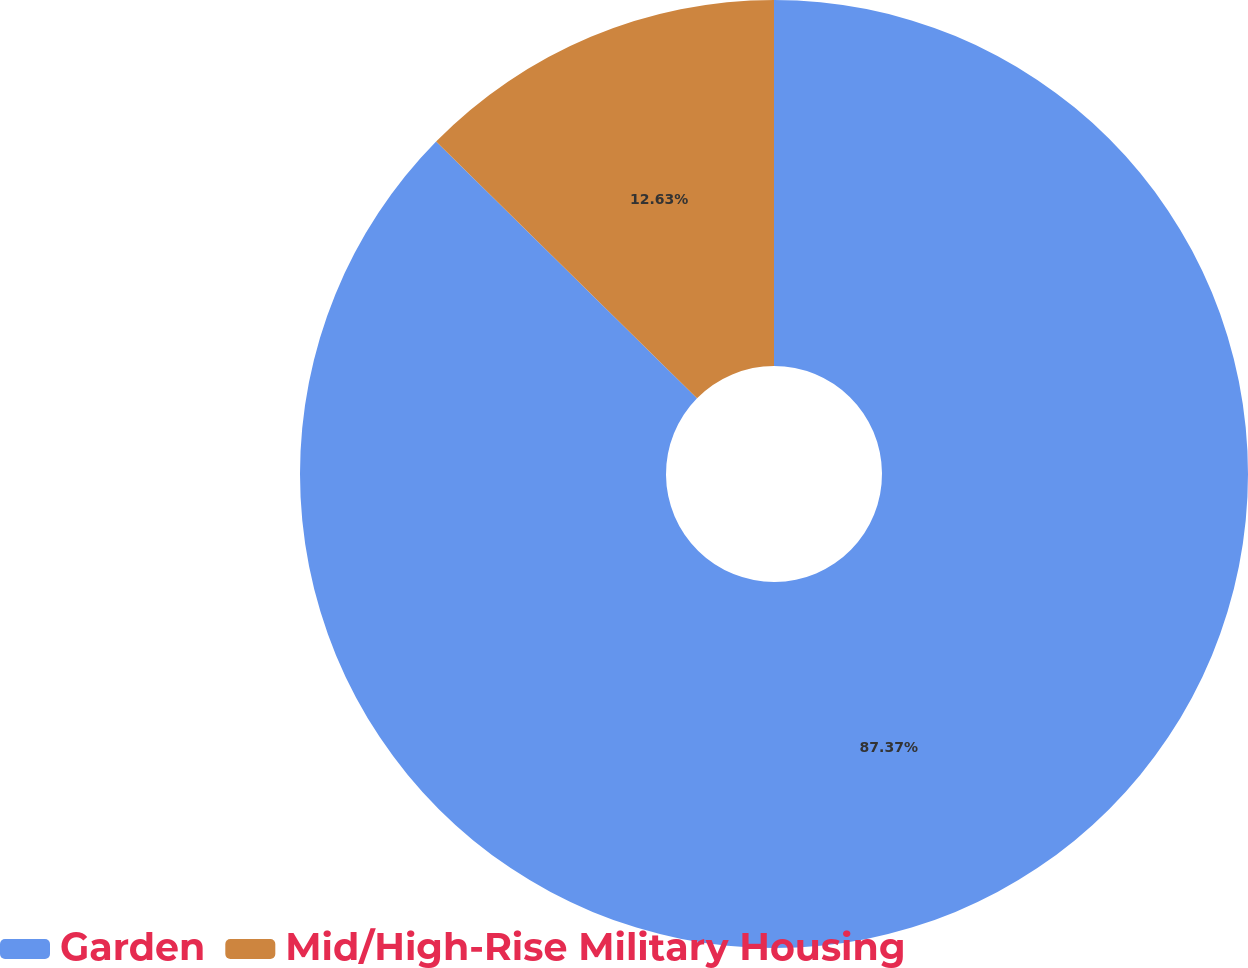<chart> <loc_0><loc_0><loc_500><loc_500><pie_chart><fcel>Garden<fcel>Mid/High-Rise Military Housing<nl><fcel>87.37%<fcel>12.63%<nl></chart> 